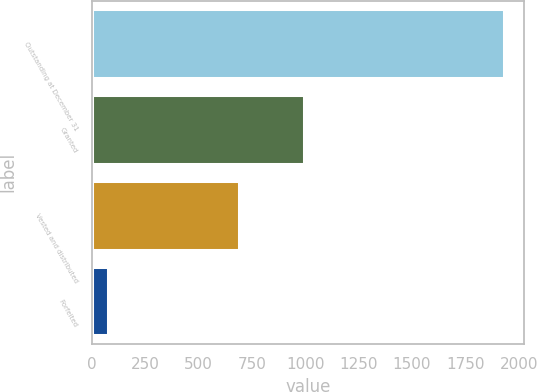<chart> <loc_0><loc_0><loc_500><loc_500><bar_chart><fcel>Outstanding at December 31<fcel>Granted<fcel>Vested and distributed<fcel>Forfeited<nl><fcel>1930<fcel>992<fcel>691<fcel>77<nl></chart> 